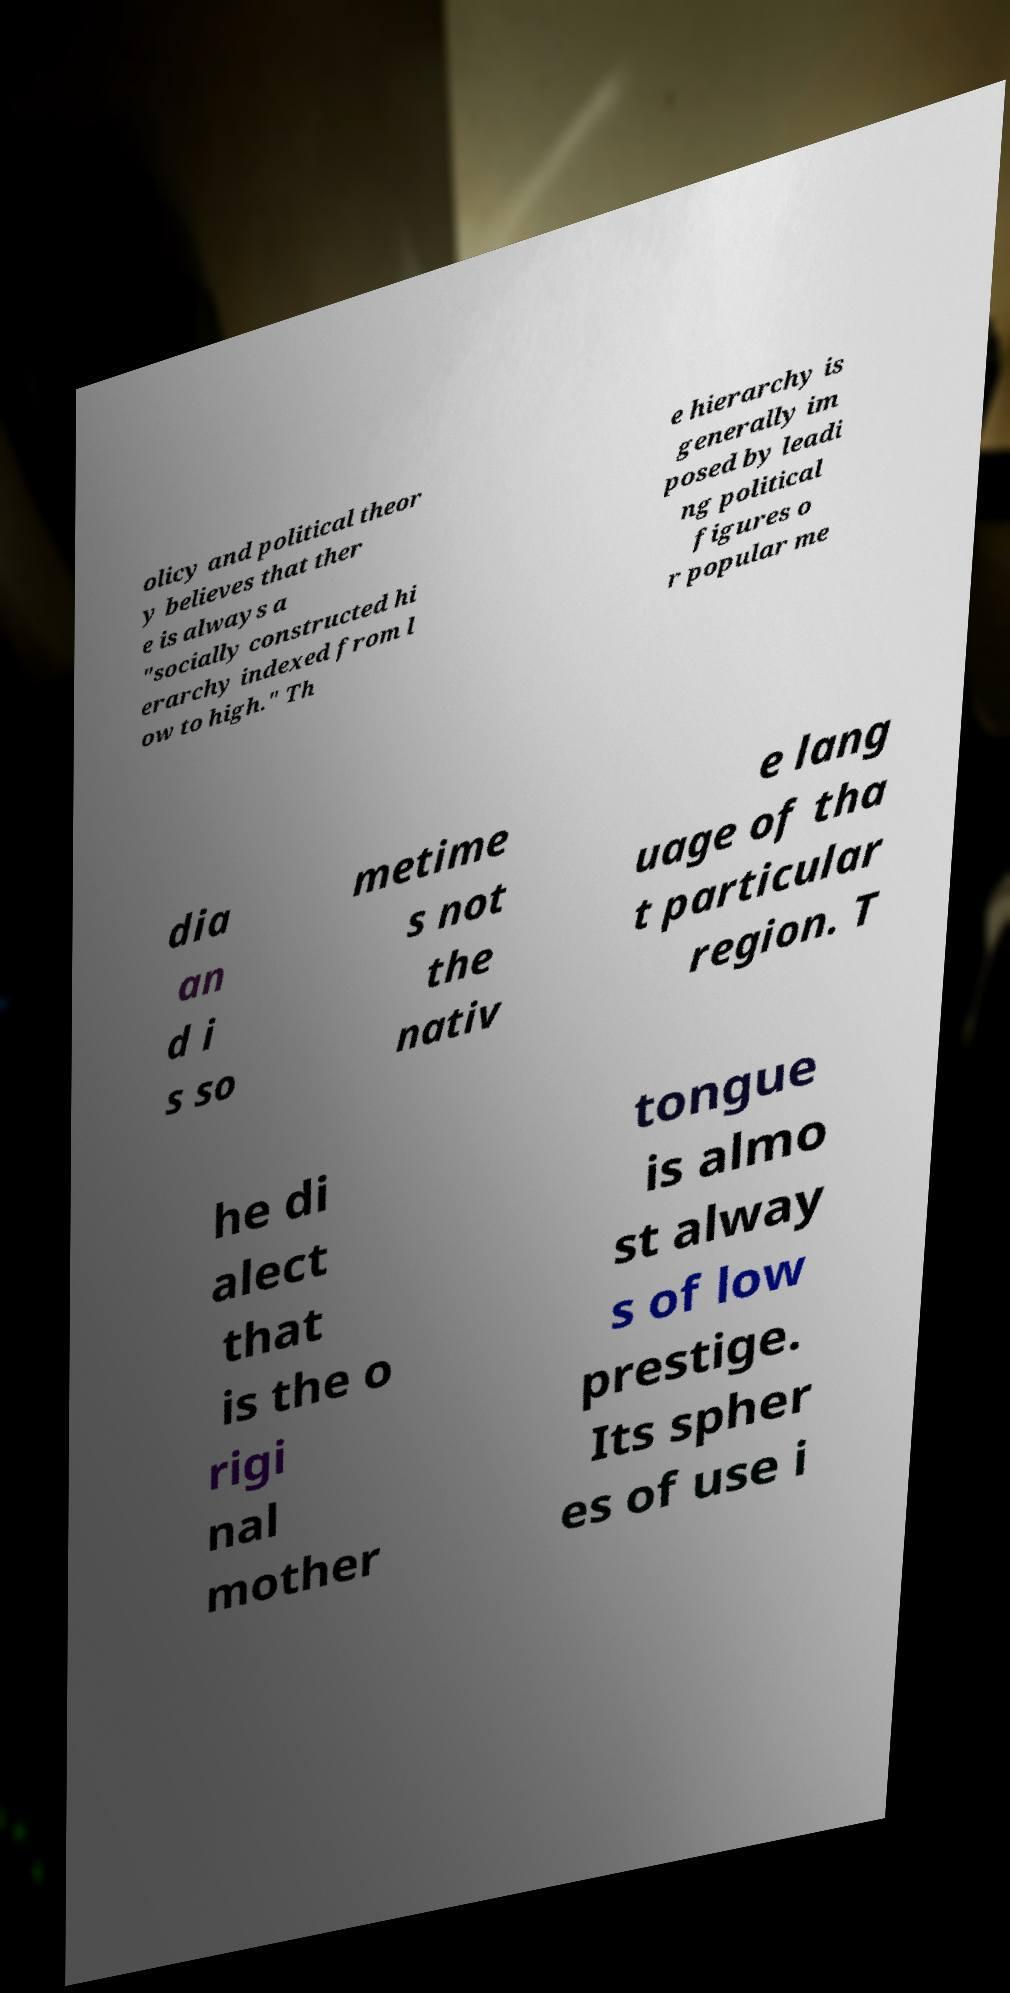Can you read and provide the text displayed in the image?This photo seems to have some interesting text. Can you extract and type it out for me? olicy and political theor y believes that ther e is always a "socially constructed hi erarchy indexed from l ow to high." Th e hierarchy is generally im posed by leadi ng political figures o r popular me dia an d i s so metime s not the nativ e lang uage of tha t particular region. T he di alect that is the o rigi nal mother tongue is almo st alway s of low prestige. Its spher es of use i 